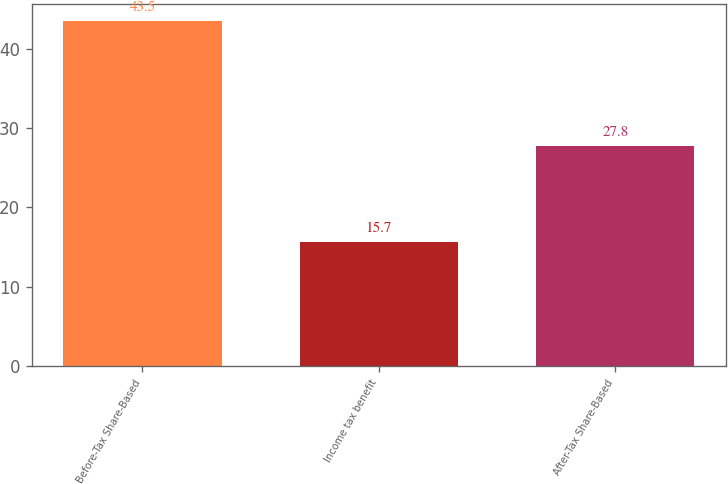<chart> <loc_0><loc_0><loc_500><loc_500><bar_chart><fcel>Before-Tax Share-Based<fcel>Income tax benefit<fcel>After-Tax Share-Based<nl><fcel>43.5<fcel>15.7<fcel>27.8<nl></chart> 